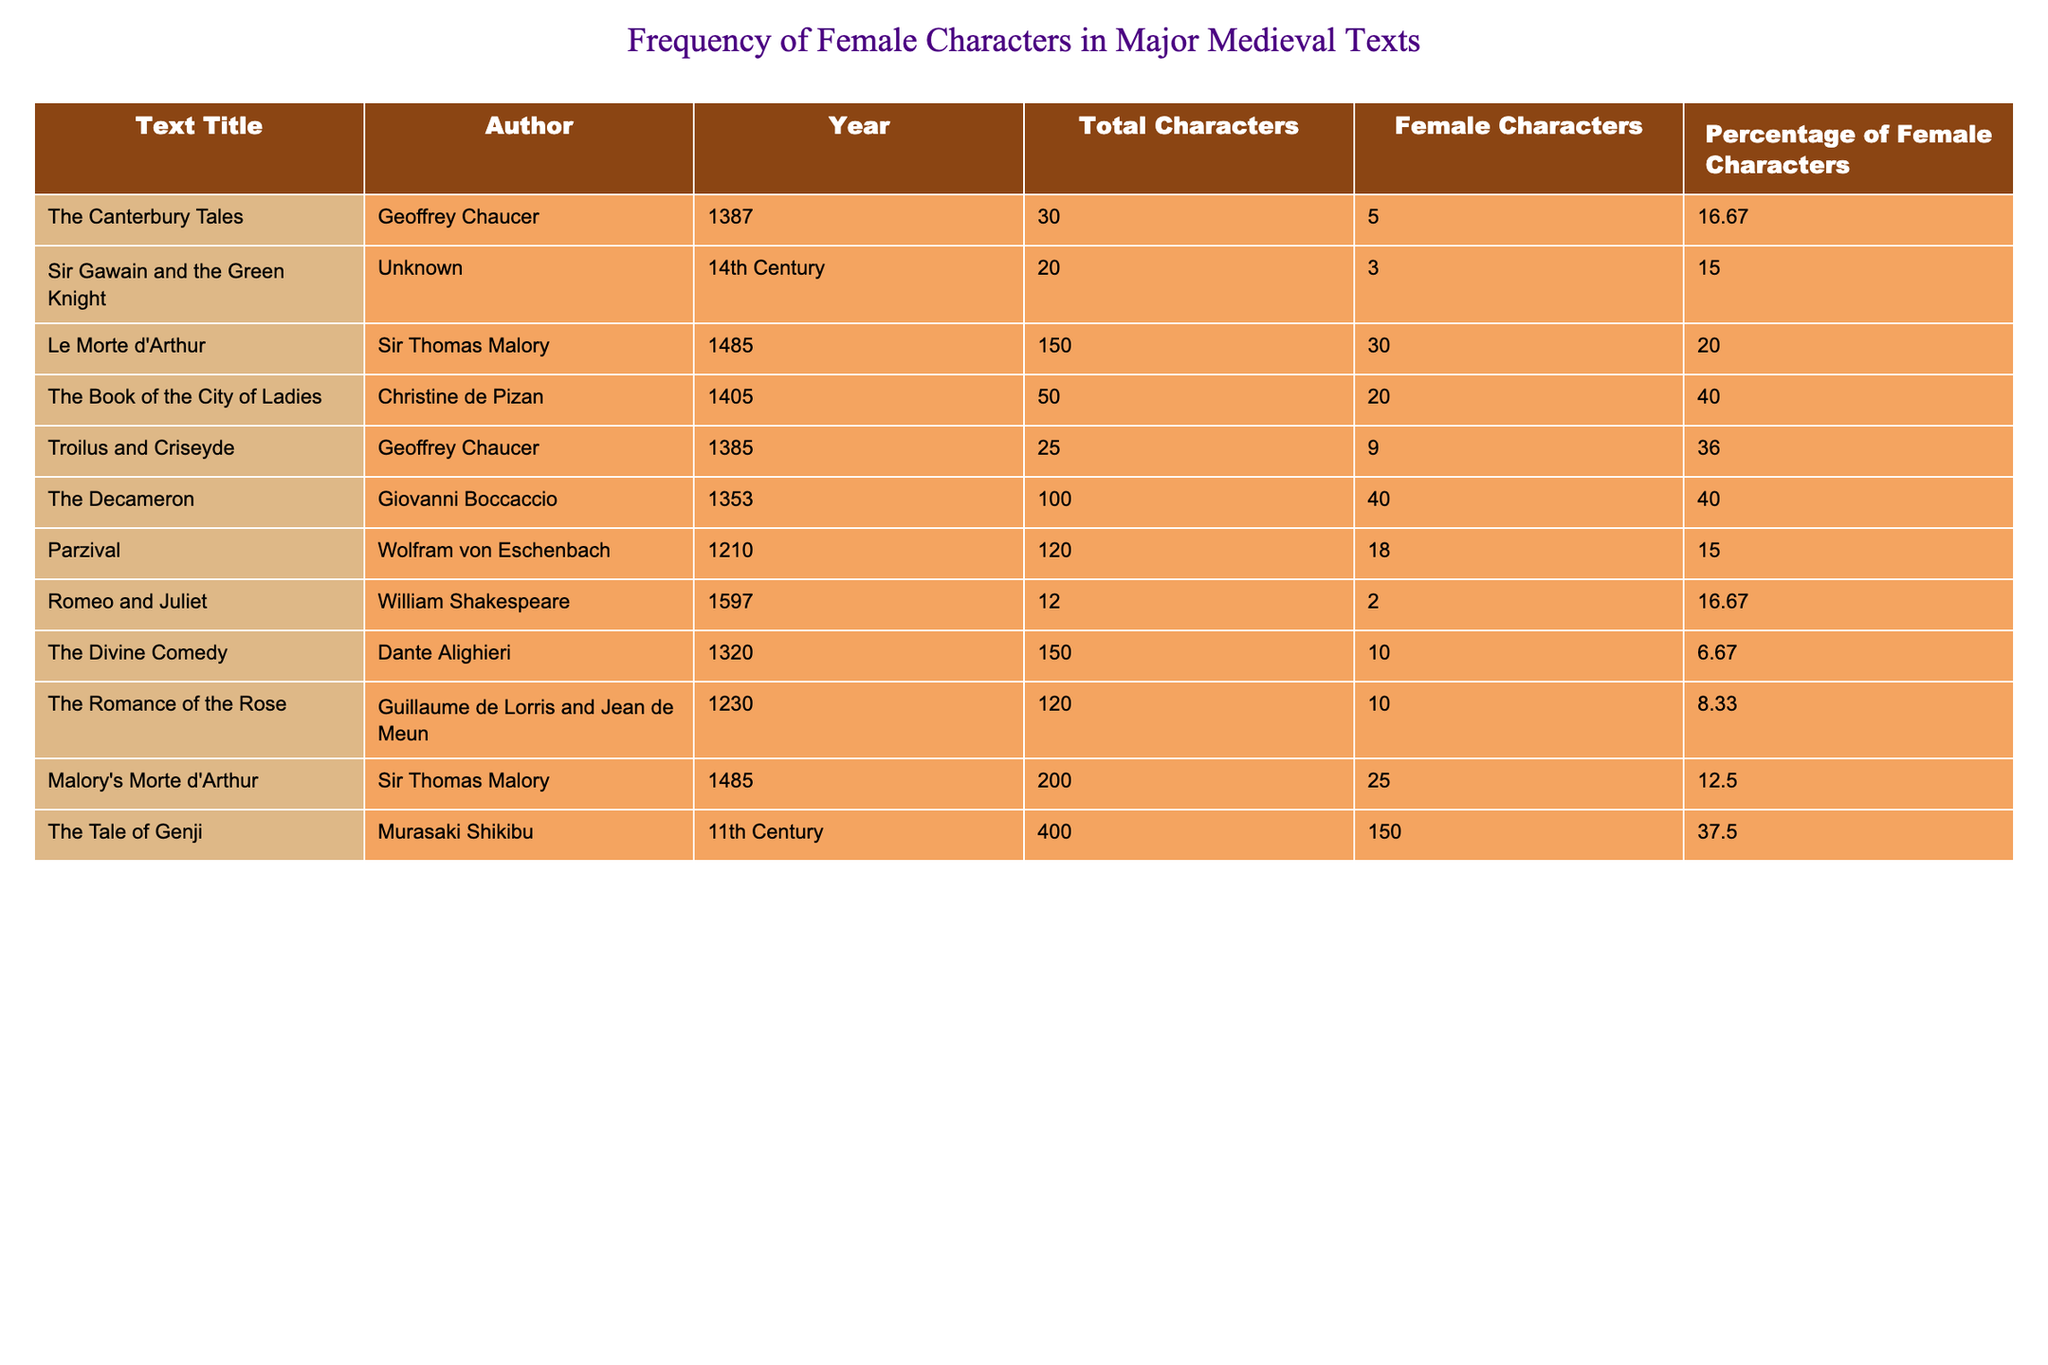What is the text with the highest percentage of female characters? By checking the "Percentage of Female Characters" column, "The Book of the City of Ladies" has the highest percentage at 40.00%.
Answer: The Book of the City of Ladies How many female characters are there in "Le Morte d'Arthur"? Referring to the table, "Le Morte d'Arthur" has 30 female characters listed in the corresponding column.
Answer: 30 Which text has the least percentage of female characters? The text with the least percentage of female characters is "The Divine Comedy" with 6.67%.
Answer: The Divine Comedy How many total characters are there across all texts? By adding the "Total Characters" column together: 30 + 20 + 150 + 50 + 25 + 100 + 120 + 12 + 150 + 120 + 200 + 400 = 1,157.
Answer: 1,157 What is the average percentage of female characters across all texts? To find the average, add the percentages: (16.67 + 15.00 + 20.00 + 40.00 + 36.00 + 40.00 + 15.00 + 16.67 + 6.67 + 8.33 + 12.50 + 37.50) =  306.34. Then divide by 12 texts: 306.34 / 12 = 25.53.
Answer: 25.53 Is it true that "Troilus and Criseyde" has more female characters than "Sir Gawain and the Green Knight"? Yes, "Troilus and Criseyde" has 9 female characters while "Sir Gawain and the Green Knight" has only 3.
Answer: Yes How many texts have 20% or more female characters? The texts "Le Morte d'Arthur", "The Book of the City of Ladies", "Troilus and Criseyde", and "The Decameron" each have at least 20% or more female characters, totaling 4 texts.
Answer: 4 What is the difference in the total number of female characters between "The Tale of Genji" and "The Divine Comedy"? "The Tale of Genji" has 150 female characters while "The Divine Comedy" has 10. The difference is 150 - 10 = 140.
Answer: 140 Identify any text where the percentage of female characters is below 10%. "The Romance of the Rose" has 8.33%, which is below 10%.
Answer: The Romance of the Rose Which author has the highest percentage of female characters in their texts? Christine de Pizan appears as the author of "The Book of the City of Ladies", which has the highest percentage of female characters at 40.00%.
Answer: Christine de Pizan 